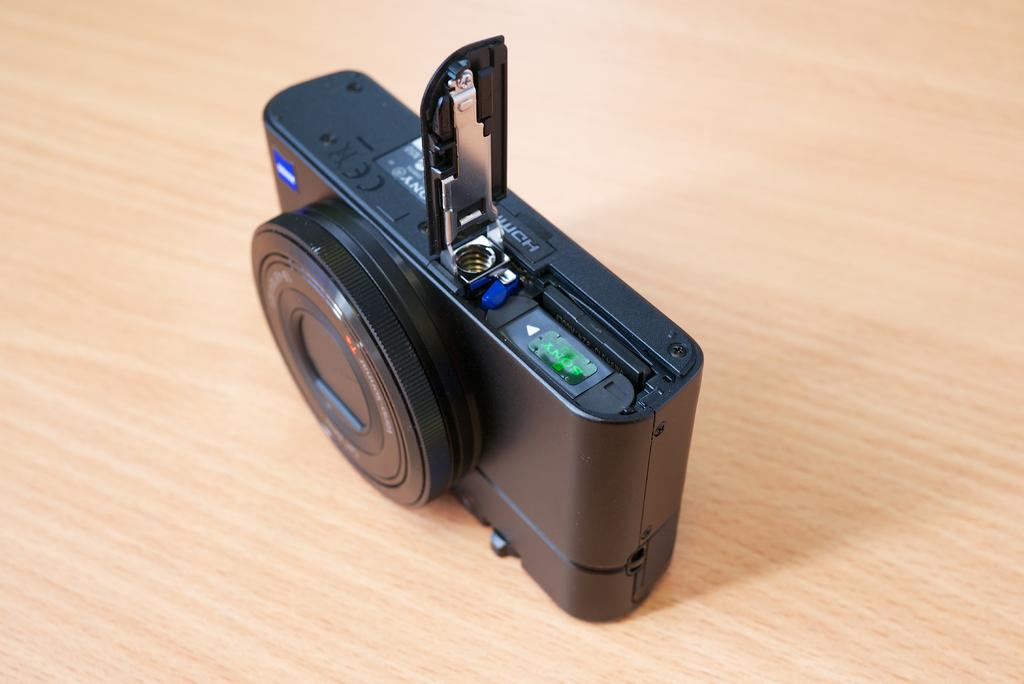What object is the main focus of the image? There is a camera in the image. Where is the camera located? The camera is on a table. What type of birds are involved in the discussion taking place near the camera in the image? There is no discussion or birds present in the image; it only features a camera on a table. 